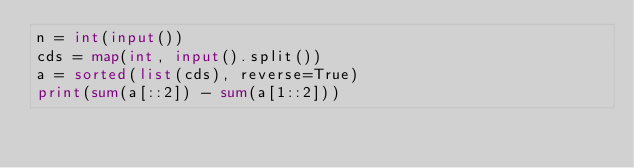<code> <loc_0><loc_0><loc_500><loc_500><_Python_>n = int(input())
cds = map(int, input().split())
a = sorted(list(cds), reverse=True)
print(sum(a[::2]) - sum(a[1::2]))</code> 